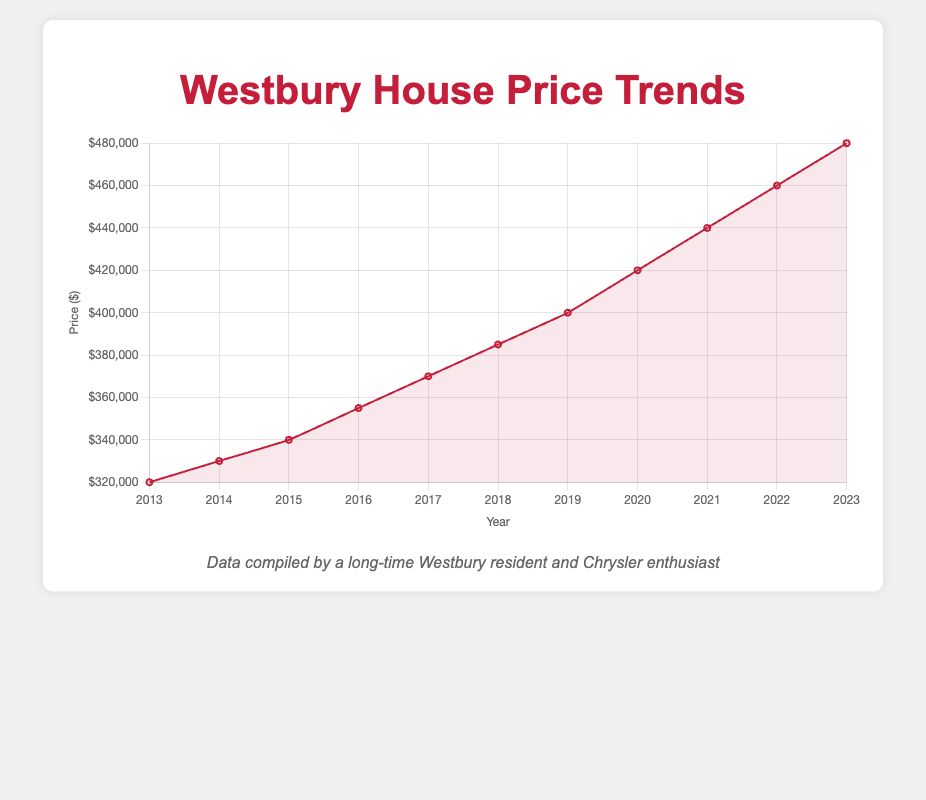What's the highest average house price in the last decade? The highest average house price can be found by inspecting the trend line and identifying the peak value. The peak is at the year 2023 with an average price of $480,000.
Answer: $480,000 Which year saw the greatest increase in average house price compared to the previous year? Compare the differences between consecutive years. The difference between 2019 and 2020 is $420,000 - $400,000 = $20,000, which is the greatest increase.
Answer: 2020 What’s the average house price over the decade? Add all the average prices from 2013 to 2023 and divide by the number of years (11): (320,000 + 330,000 + 340,000 + 355,000 + 370,000 + 385,000 + 400,000 + 420,000 + 440,000 + 460,000 + 480,000) / 11 = 3,700,000 / 11 = 336,364.
Answer: $336,364 By how much did the average house price increase from 2013 to 2023? Subtract the average price in 2013 from the average price in 2023: 480,000 - 320,000 = 160,000.
Answer: $160,000 Compare the average house prices in 2015 and 2020. Which year had the higher price and by how much? The average price in 2015 is $340,000, and in 2020, it is $420,000. Subtract the 2015 price from the 2020 price: 420,000 - 340,000 = 80,000.
Answer: 2020, $80,000 What is the median house price over the decade? Order the prices from lowest to highest and find the middle value. For the given data, the middle (6th) value is the median: 385,000.
Answer: $385,000 How many years had an average house price below $400,000? Identify the years with average prices below $400,000: 2013 to 2018 (6 years).
Answer: 6 years Is the trend line for the average house price generally increasing, decreasing, or stable over the last decade? Observe the trend from the chart. The line consistently rises from 2013 to 2023, indicating an increasing trend.
Answer: Increasing In which year did the average house price first exceed $350,000? Find the first year where the average price goes above $350,000. This occurs in 2016 with a price of $355,000.
Answer: 2016 